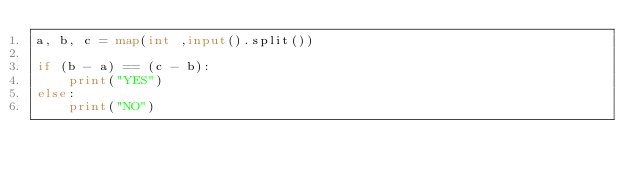<code> <loc_0><loc_0><loc_500><loc_500><_Python_>a, b, c = map(int ,input().split())

if (b - a) == (c - b):
    print("YES")
else:
    print("NO")</code> 